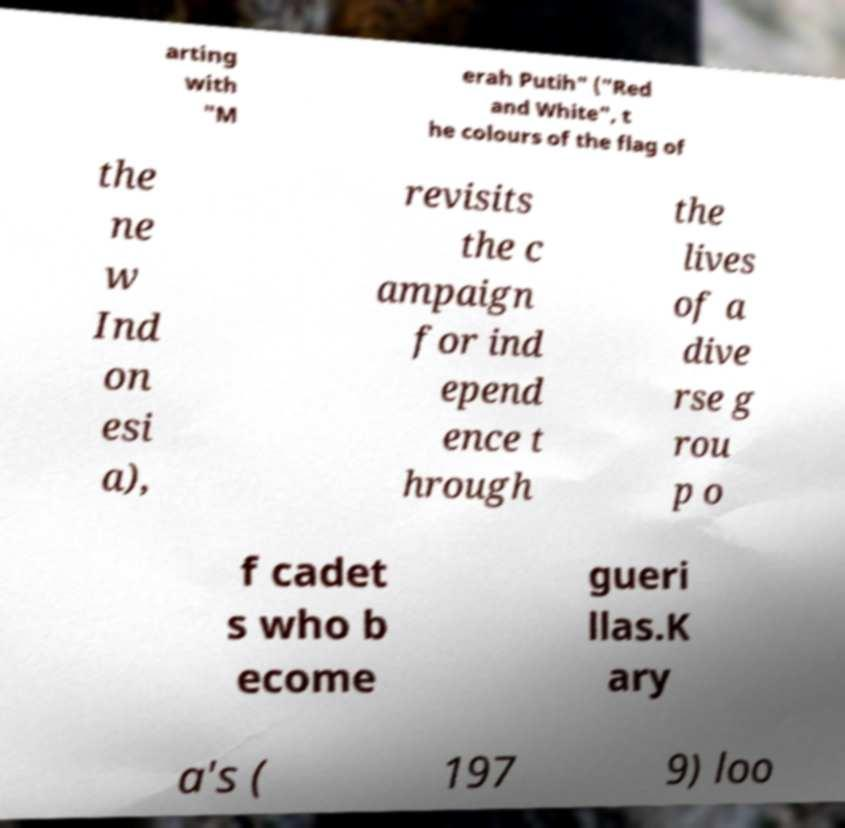Can you read and provide the text displayed in the image?This photo seems to have some interesting text. Can you extract and type it out for me? arting with "M erah Putih" ("Red and White", t he colours of the flag of the ne w Ind on esi a), revisits the c ampaign for ind epend ence t hrough the lives of a dive rse g rou p o f cadet s who b ecome gueri llas.K ary a's ( 197 9) loo 